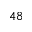<formula> <loc_0><loc_0><loc_500><loc_500>^ { 4 8 }</formula> 